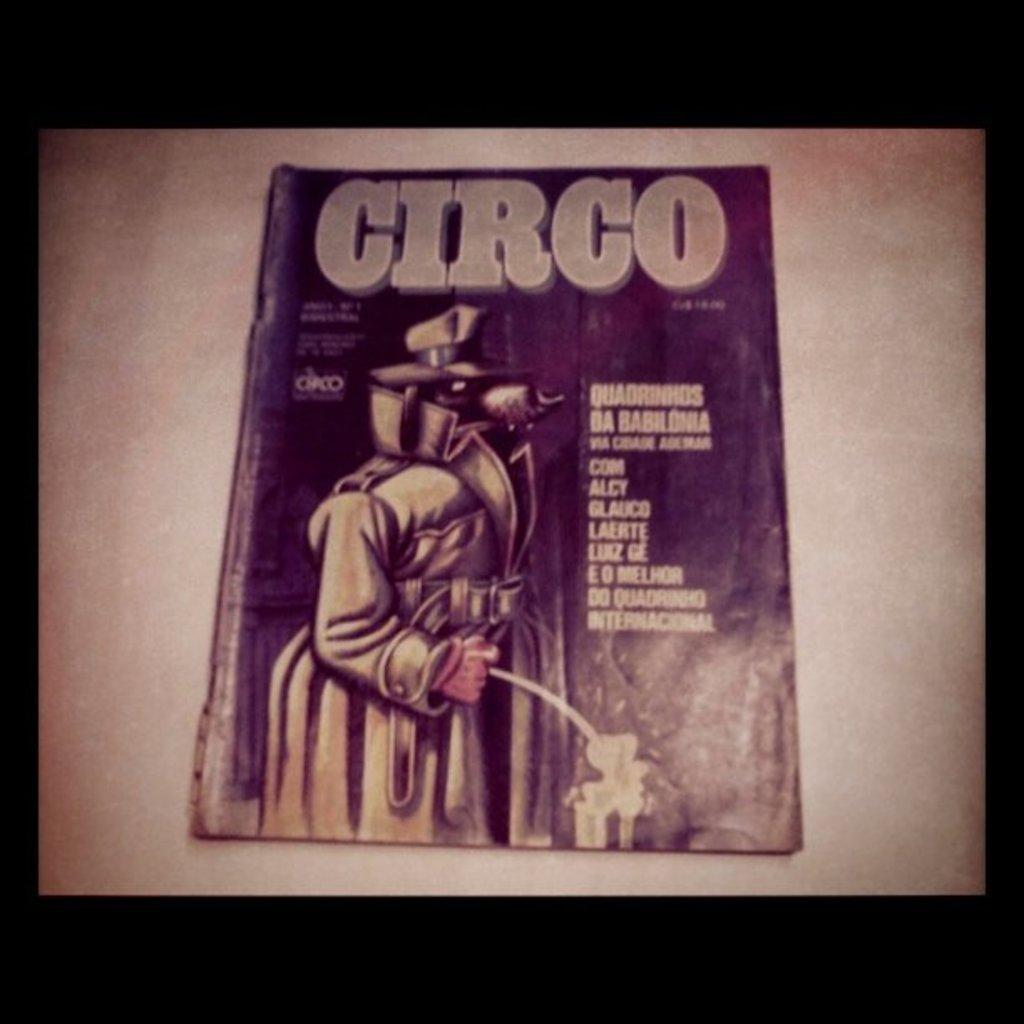Provide a one-sentence caption for the provided image. A Circo book called Quadrinhds Da Babhonla Com Alcy. 